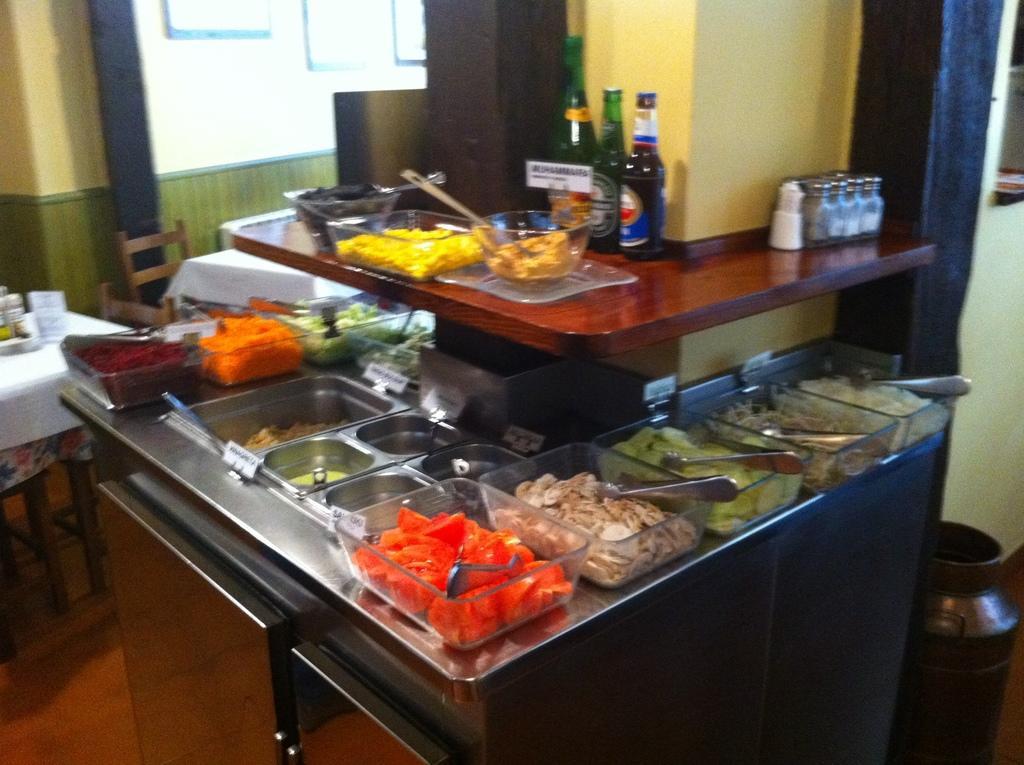Can you describe this image briefly? In this picture I can see few food items in the bowls and I can see few bottles and few salt and pepper shakers on the counter top and I can see a table and couple of chairs on the left side of the picture and looks like few photo frames on the wall. 